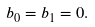Convert formula to latex. <formula><loc_0><loc_0><loc_500><loc_500>b _ { 0 } = b _ { 1 } = 0 .</formula> 